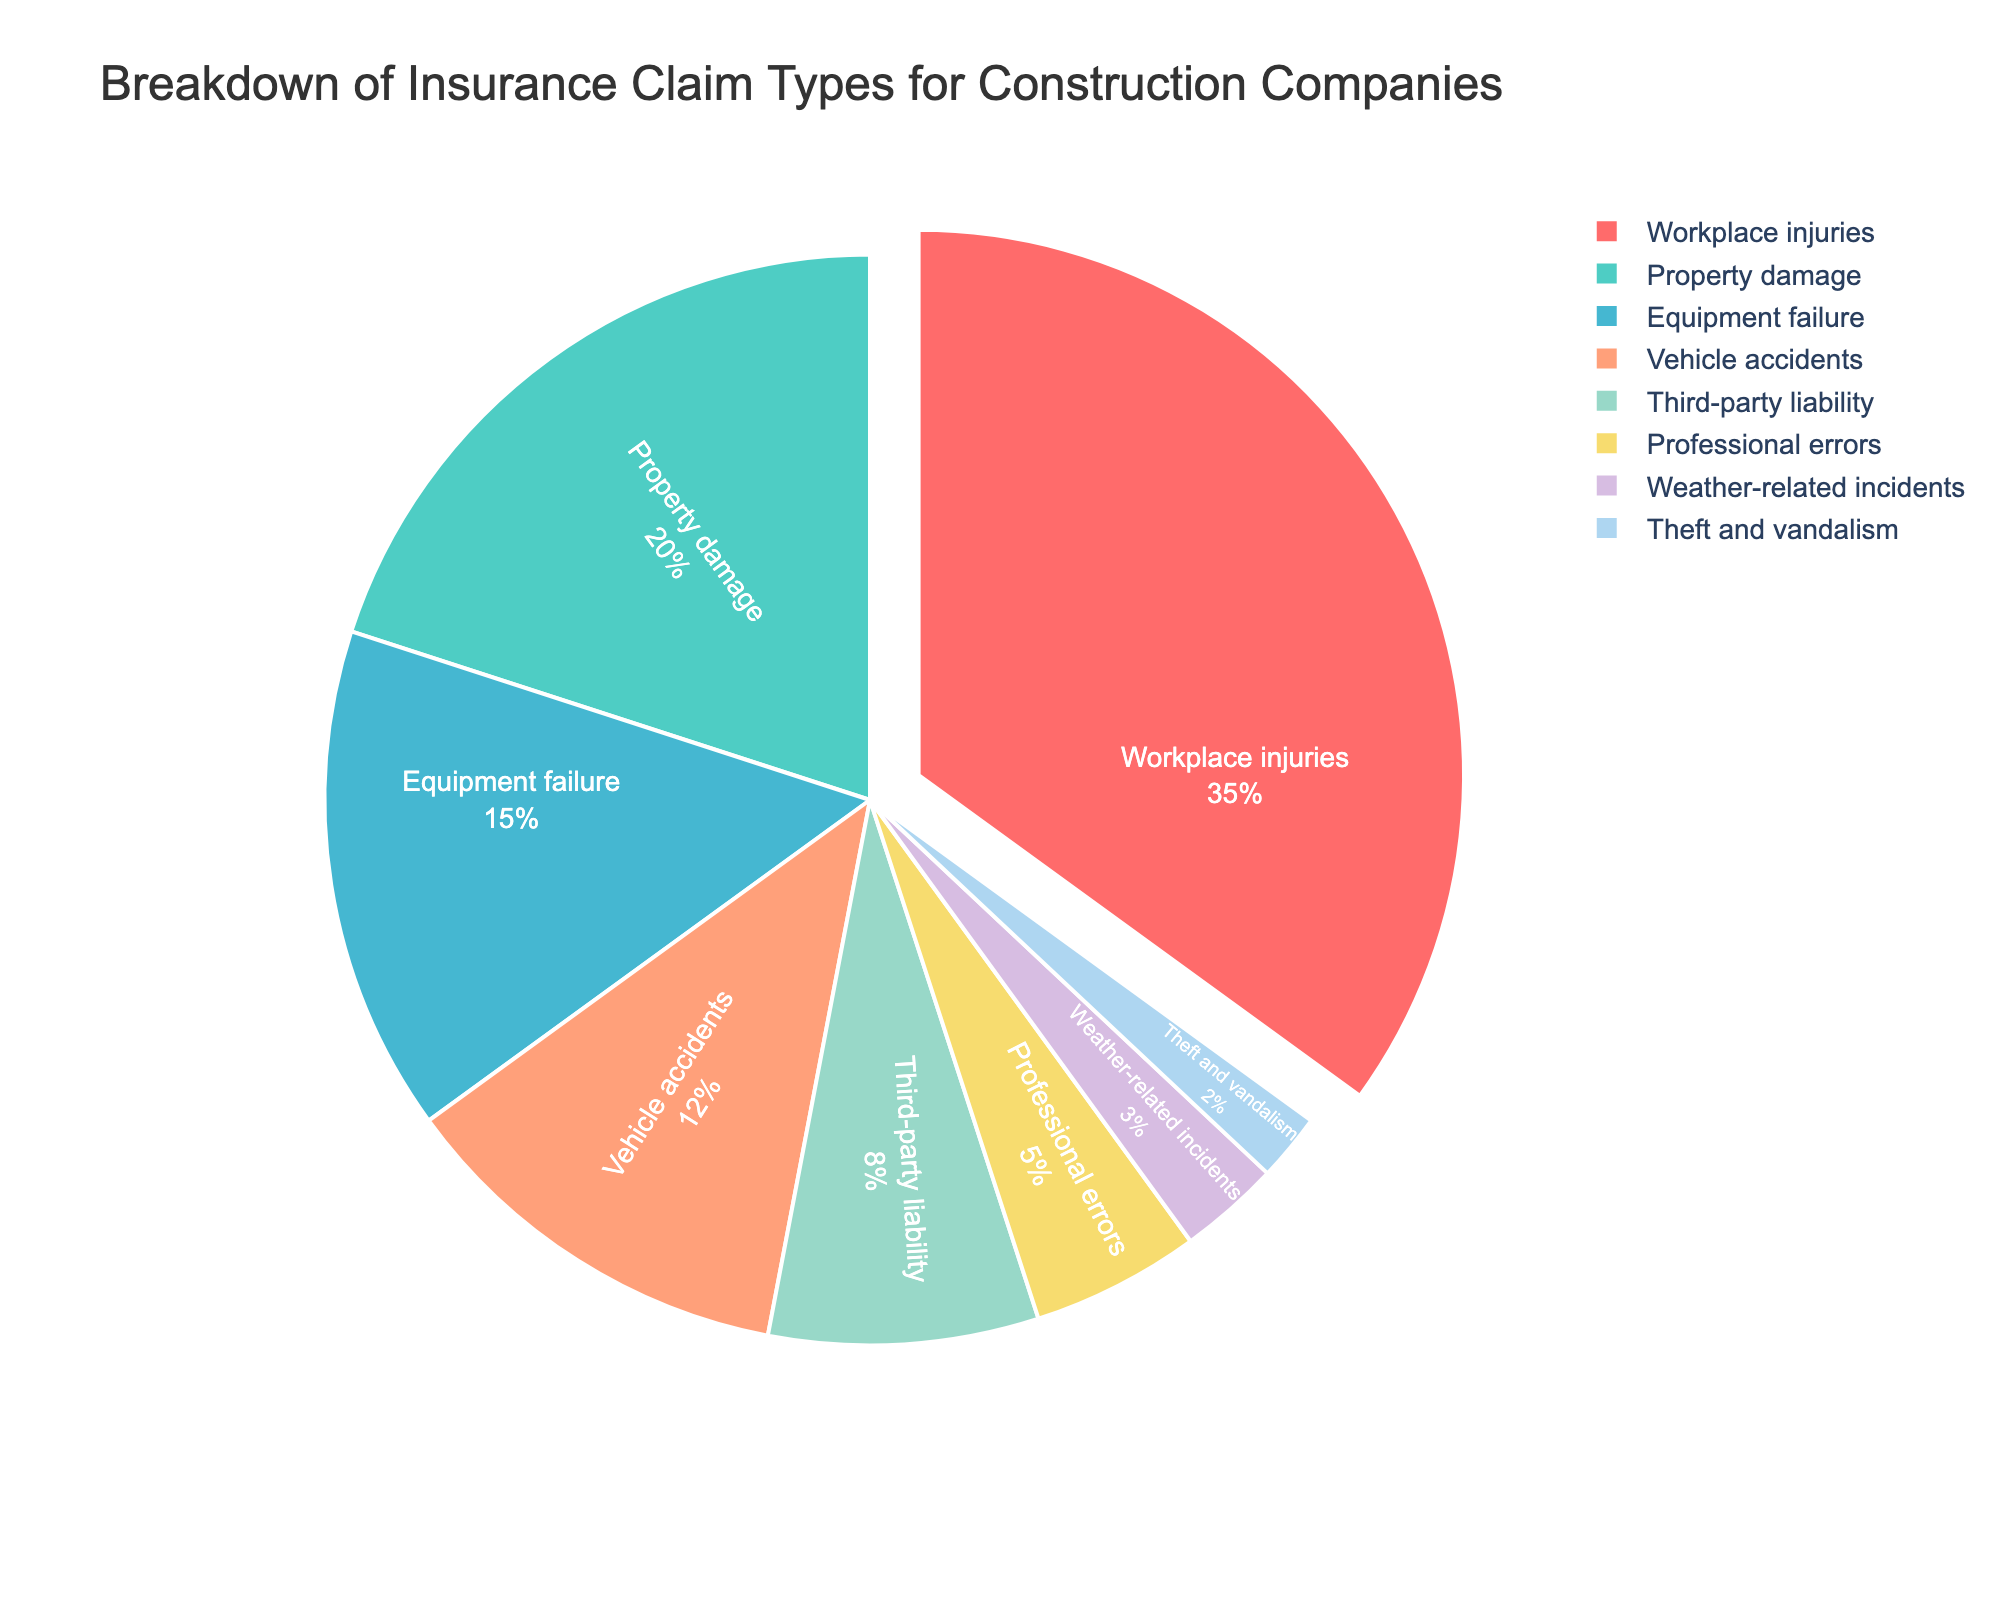Which category has the highest percentage of insurance claims? The largest slice of the pie chart, representing the highest percentage, is labeled "Workplace injuries" and occupies 35% of the pie.
Answer: Workplace injuries Which category has the smallest percentage of insurance claims? The smallest slice of the pie chart, representing the smallest percentage, is labeled "Theft and vandalism" and occupies 2% of the pie.
Answer: Theft and vandalism What is the combined percentage of Workplace injuries and Property damage claims? Workplace injuries account for 35% and Property damage accounts for 20%. Adding these two percentages together, 35% + 20% = 55%.
Answer: 55% How does the percentage of Equipment failure claims compare to that of Vehicle accidents? Equipment failure claims occupy 15% of the pie chart, while Vehicle accidents occupy 12%. Equipment failure claims are 3 percentage points higher than Vehicle accidents.
Answer: Equipment failure claims are higher What is the combined percentage of all the incidents that are less than 10%? The categories with less than 10% are Third-party liability (8%), Professional errors (5%), Weather-related incidents (3%), and Theft and vandalism (2%). Adding these together, 8% + 5% + 3% + 2% = 18%.
Answer: 18% How much greater is the percentage of Property damage claims compared to Professional errors claims? Property damage claims are 20% while Professional errors claims are 5%. Subtracting these, 20% - 5% = 15%.
Answer: 15% What is the combined percentage of the three largest categories? The three largest categories are Workplace injuries (35%), Property damage (20%), and Equipment failure (15%). Adding these percentages together, 35% + 20% + 15% = 70%.
Answer: 70% Among all categories, which one has the closest percentage to the average percentage of all categories? First, calculate the average percentage: (35% + 20% + 15% + 12% + 8% + 5% + 3% + 2%) / 8 = 12.5%. The category closest to this average percentage is Vehicle accidents at 12%.
Answer: Vehicle accidents How does the total percentage of Equipment failure and Vehicle accidents compare to Property damage? Equipment failure is 15% and Vehicle accidents are 12%. Combining these, 15% + 12% = 27%. Property damage is 20%. So, 27% is greater than 20%.
Answer: Greater than What percentage of claims do not relate to direct physical damage (excluding Property damage, Equipment failure, Vehicle accidents, Weather-related incidents, and Theft and vandalism)? Categories that involve direct physical damage are excluded: Property damage (20%), Equipment failure (15%), Vehicle accidents (12%), Weather-related incidents (3%), and Theft and vandalism (2%). Sum these percentages: 20% + 15% + 12% + 3% + 2% = 52%. The remaining percentage would be 100% - 52% = 48%.
Answer: 48% 